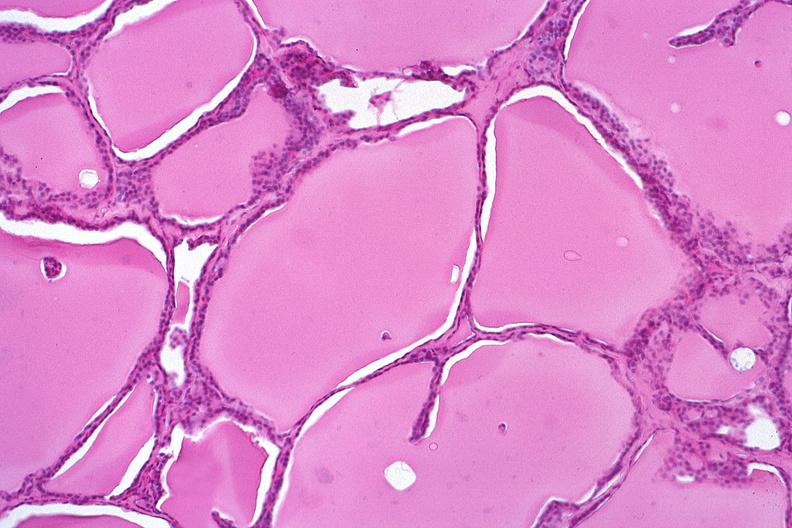s endocrine present?
Answer the question using a single word or phrase. Yes 